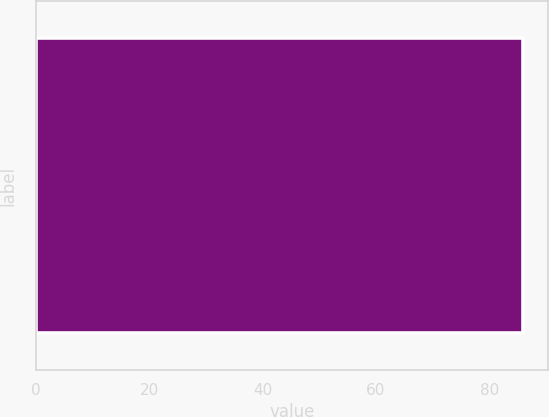Convert chart. <chart><loc_0><loc_0><loc_500><loc_500><bar_chart><ecel><nl><fcel>86<nl></chart> 